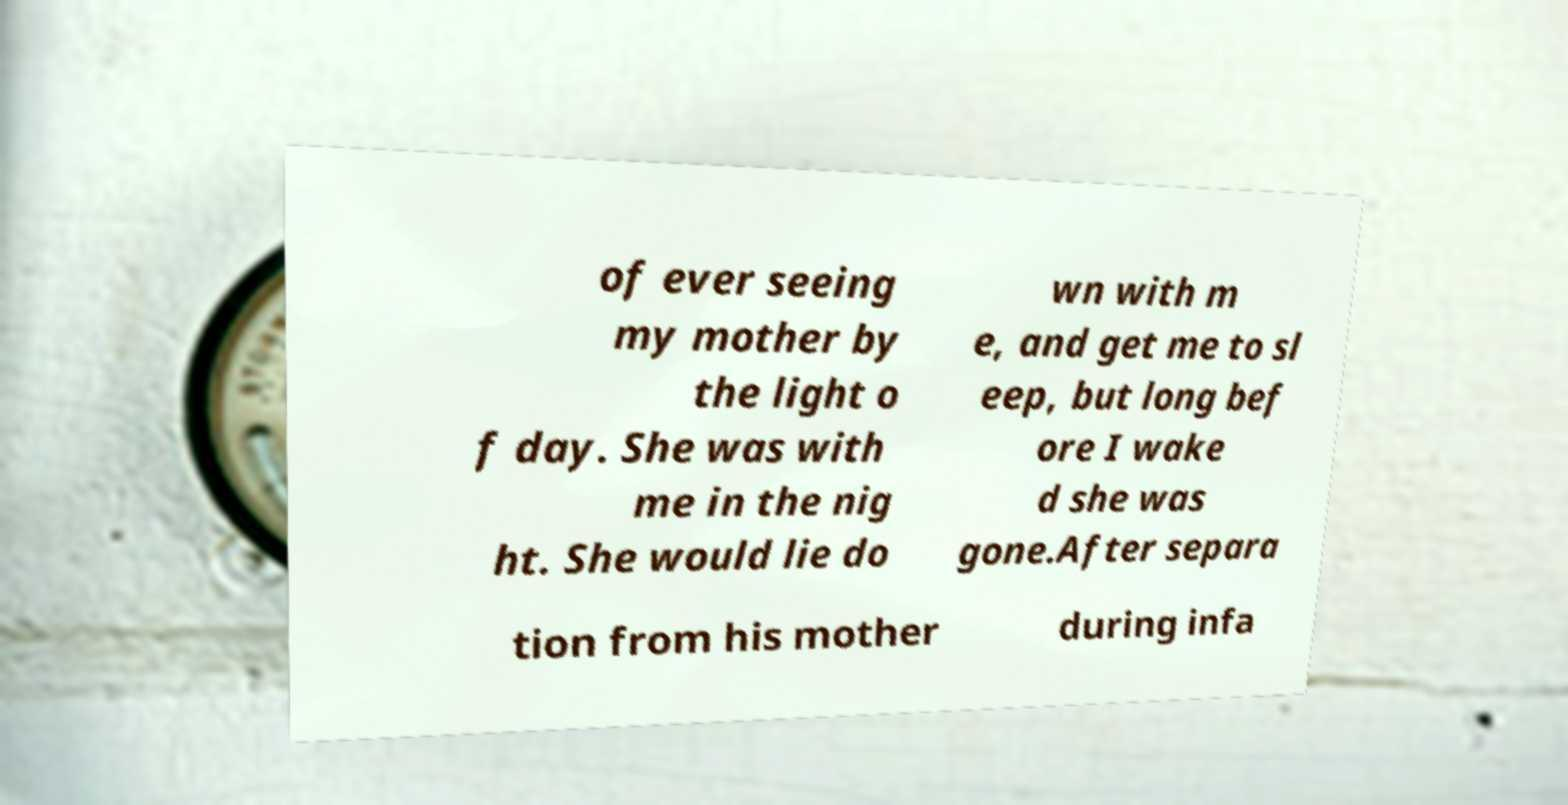Can you read and provide the text displayed in the image?This photo seems to have some interesting text. Can you extract and type it out for me? of ever seeing my mother by the light o f day. She was with me in the nig ht. She would lie do wn with m e, and get me to sl eep, but long bef ore I wake d she was gone.After separa tion from his mother during infa 